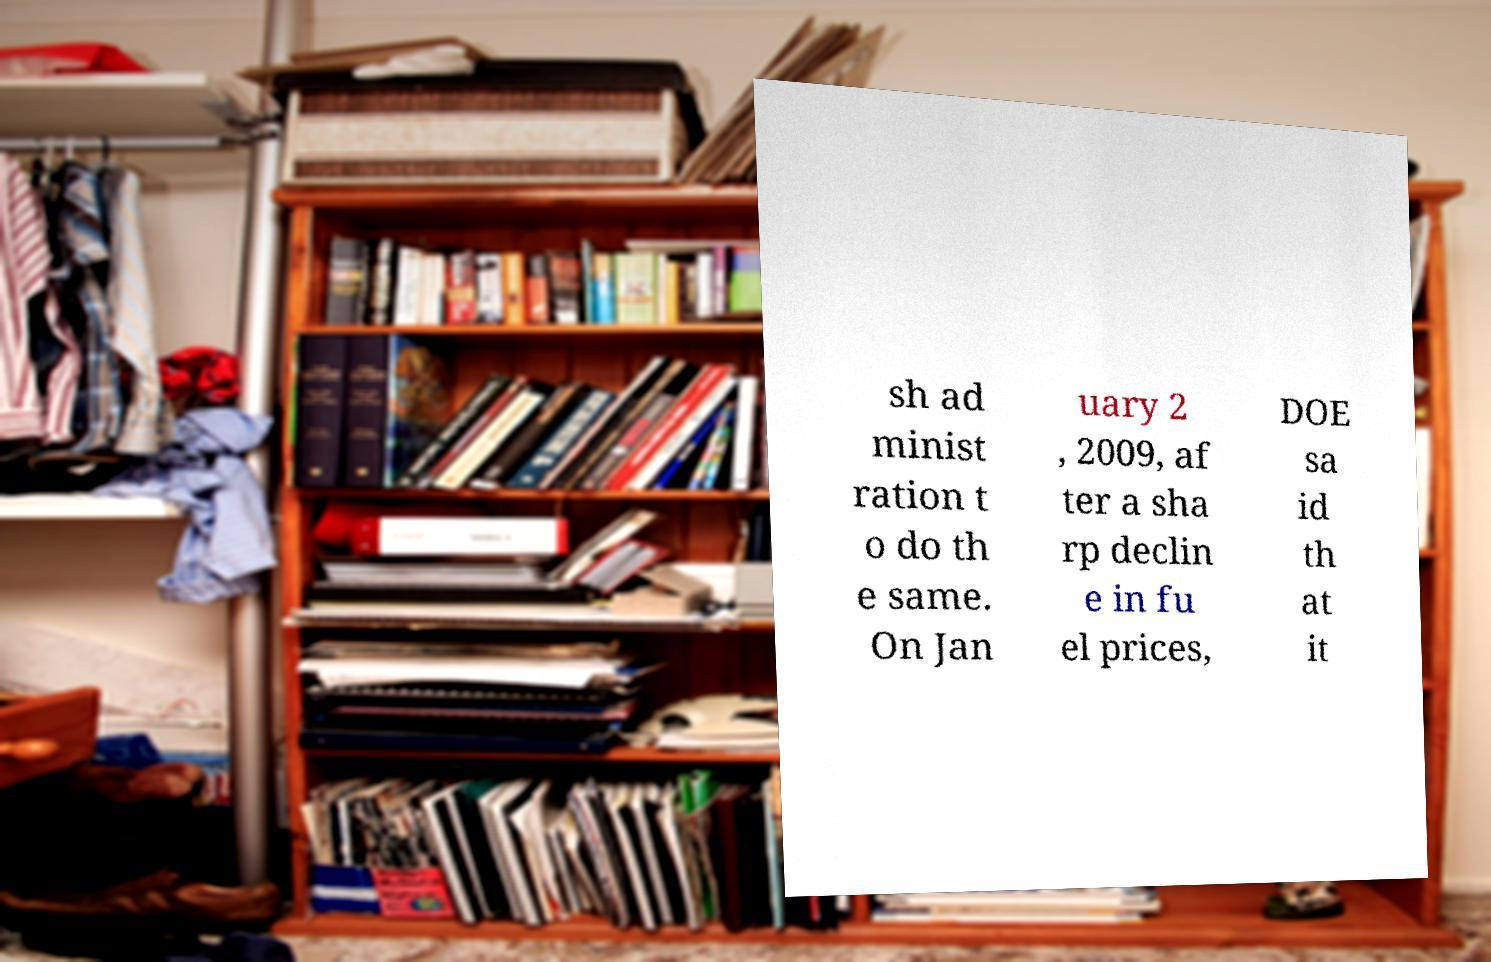Please identify and transcribe the text found in this image. sh ad minist ration t o do th e same. On Jan uary 2 , 2009, af ter a sha rp declin e in fu el prices, DOE sa id th at it 